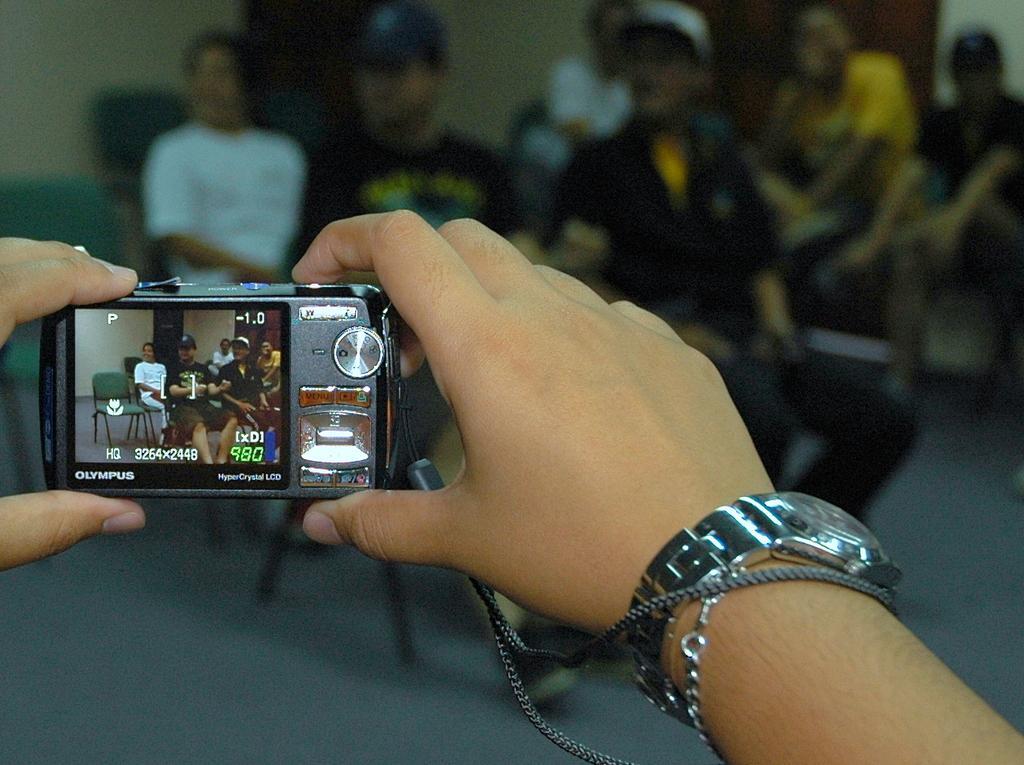Describe this image in one or two sentences. In this image I can see a hand of a person holding a camera. In the background I can see few more people sitting on chairs. 